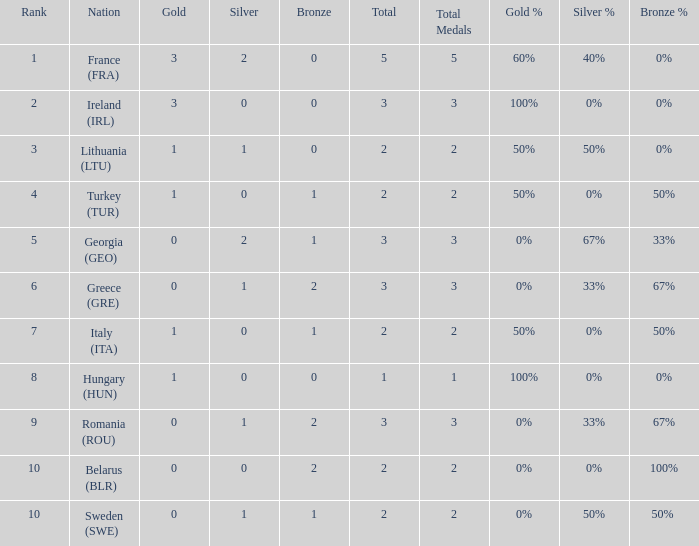What's the total of rank 8 when Silver medals are 0 and gold is more than 1? 0.0. 